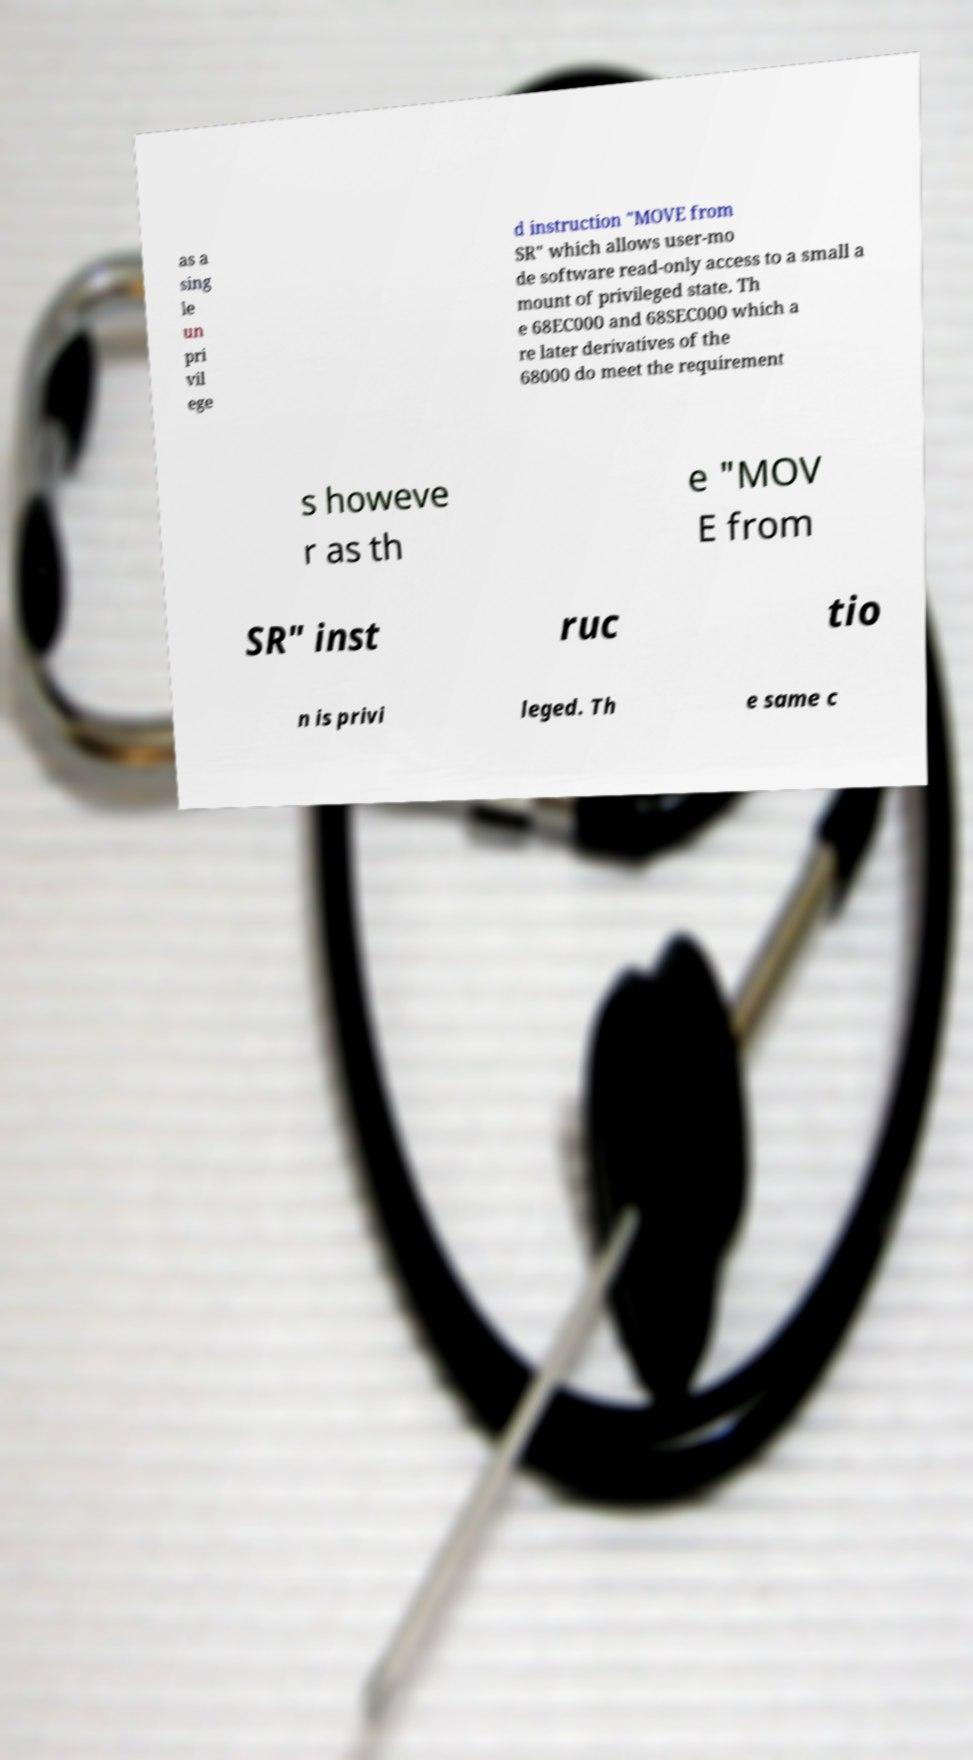What messages or text are displayed in this image? I need them in a readable, typed format. as a sing le un pri vil ege d instruction "MOVE from SR" which allows user-mo de software read-only access to a small a mount of privileged state. Th e 68EC000 and 68SEC000 which a re later derivatives of the 68000 do meet the requirement s howeve r as th e "MOV E from SR" inst ruc tio n is privi leged. Th e same c 